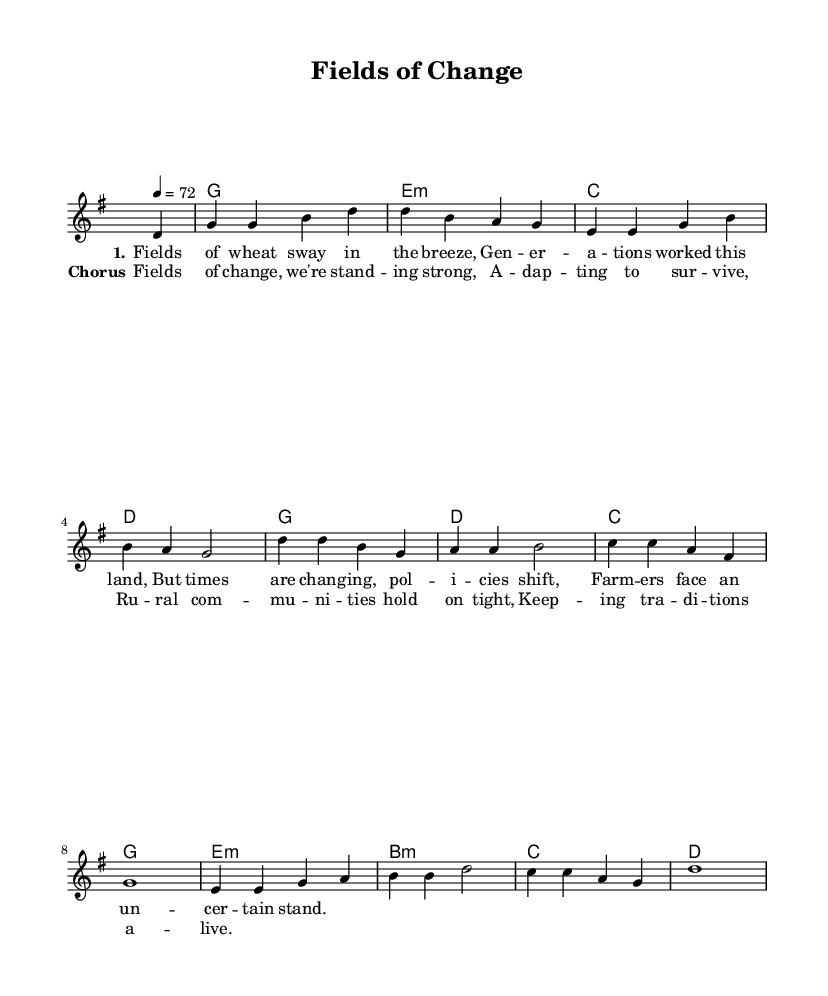What is the key signature of this music? The key signature is G major, which has one sharp (F#). This is seen at the beginning of the score where the key signature is indicated.
Answer: G major What is the time signature of the piece? The time signature is 4/4, which indicates there are four beats in each measure and a quarter note receives one beat. This is also displayed at the beginning of the score.
Answer: 4/4 What is the tempo marking of the music? The tempo is indicated as quarter note equals 72 beats per minute (tempo marking in the score). This guides the performer on how fast to play the piece.
Answer: 72 How many verses are in this song? The song contains one verse as indicated by the lyrics section where only one verse is presented before the chorus.
Answer: 1 What is the primary theme of the lyrics in this ballad? The primary theme revolves around the impact of changing agricultural policies on farming communities, as reflected in the lyrics discussing the challenges faced by farmers.
Answer: Agricultural policies What chords are used in the chorus section? The chorus section primarily uses C, D, G, and E minor chords. These chords are indicated in the harmonies section of the sheet music throughout the chorus lyrics.
Answer: C, D, G, E minor How does the melody relate to the lyrics in this ballad? The melody is designed to complement the poetic structure of the lyrics, making use of phrasing that aligns with the natural rhythm and emphasis found in the text, enhancing the emotional expression of the theme.
Answer: Emotional expression 